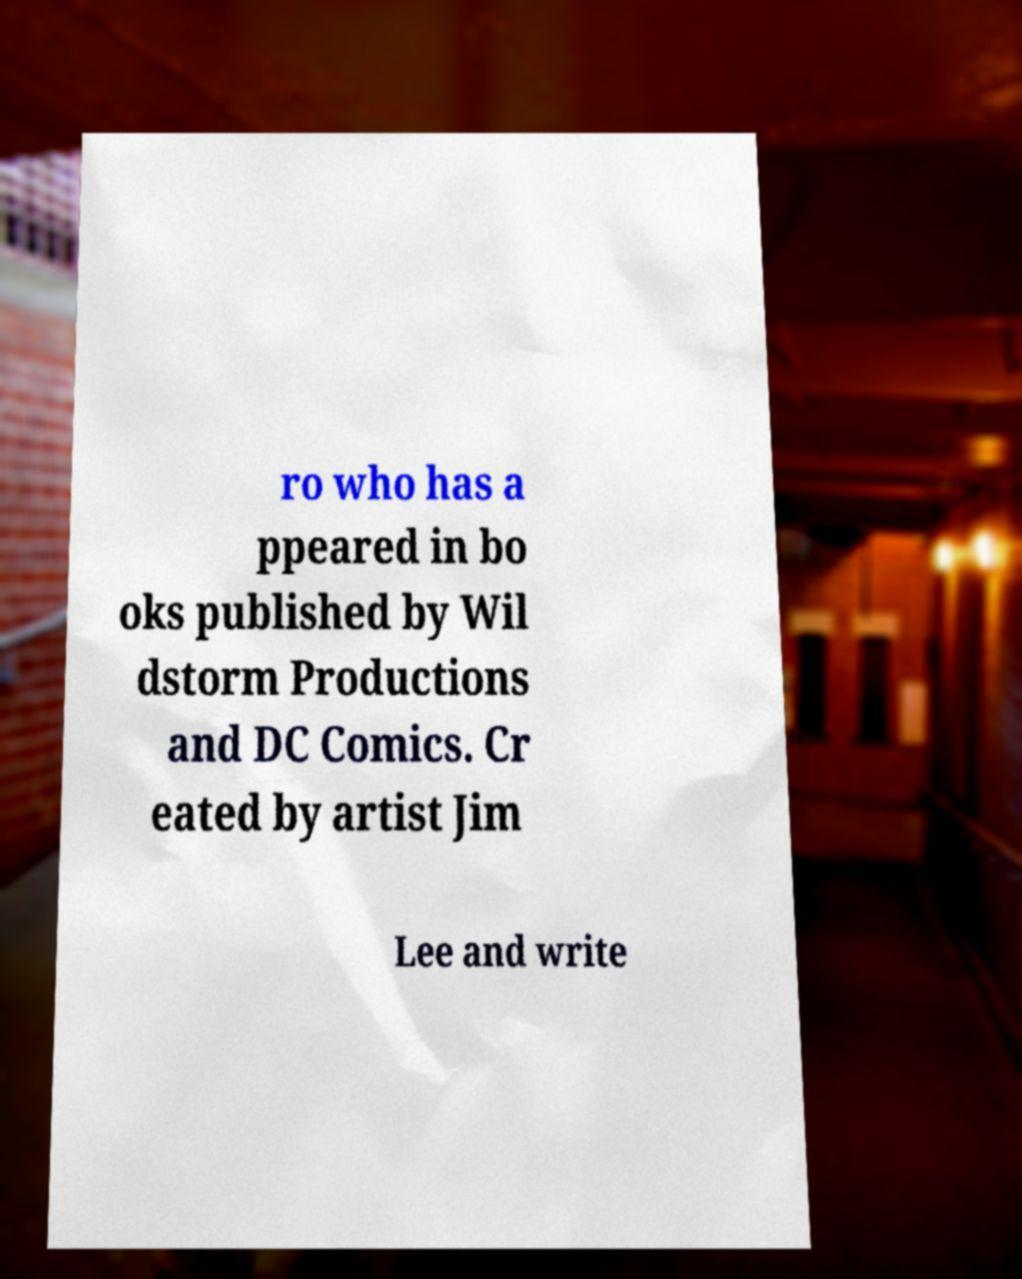Could you extract and type out the text from this image? ro who has a ppeared in bo oks published by Wil dstorm Productions and DC Comics. Cr eated by artist Jim Lee and write 